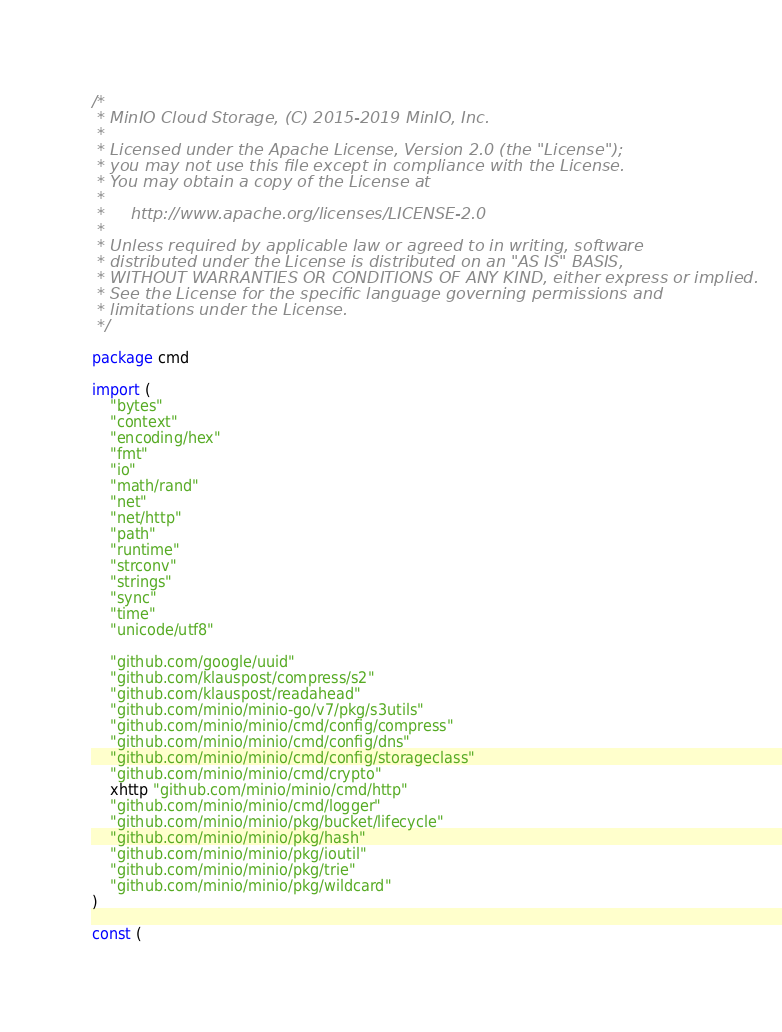Convert code to text. <code><loc_0><loc_0><loc_500><loc_500><_Go_>/*
 * MinIO Cloud Storage, (C) 2015-2019 MinIO, Inc.
 *
 * Licensed under the Apache License, Version 2.0 (the "License");
 * you may not use this file except in compliance with the License.
 * You may obtain a copy of the License at
 *
 *     http://www.apache.org/licenses/LICENSE-2.0
 *
 * Unless required by applicable law or agreed to in writing, software
 * distributed under the License is distributed on an "AS IS" BASIS,
 * WITHOUT WARRANTIES OR CONDITIONS OF ANY KIND, either express or implied.
 * See the License for the specific language governing permissions and
 * limitations under the License.
 */

package cmd

import (
	"bytes"
	"context"
	"encoding/hex"
	"fmt"
	"io"
	"math/rand"
	"net"
	"net/http"
	"path"
	"runtime"
	"strconv"
	"strings"
	"sync"
	"time"
	"unicode/utf8"

	"github.com/google/uuid"
	"github.com/klauspost/compress/s2"
	"github.com/klauspost/readahead"
	"github.com/minio/minio-go/v7/pkg/s3utils"
	"github.com/minio/minio/cmd/config/compress"
	"github.com/minio/minio/cmd/config/dns"
	"github.com/minio/minio/cmd/config/storageclass"
	"github.com/minio/minio/cmd/crypto"
	xhttp "github.com/minio/minio/cmd/http"
	"github.com/minio/minio/cmd/logger"
	"github.com/minio/minio/pkg/bucket/lifecycle"
	"github.com/minio/minio/pkg/hash"
	"github.com/minio/minio/pkg/ioutil"
	"github.com/minio/minio/pkg/trie"
	"github.com/minio/minio/pkg/wildcard"
)

const (</code> 